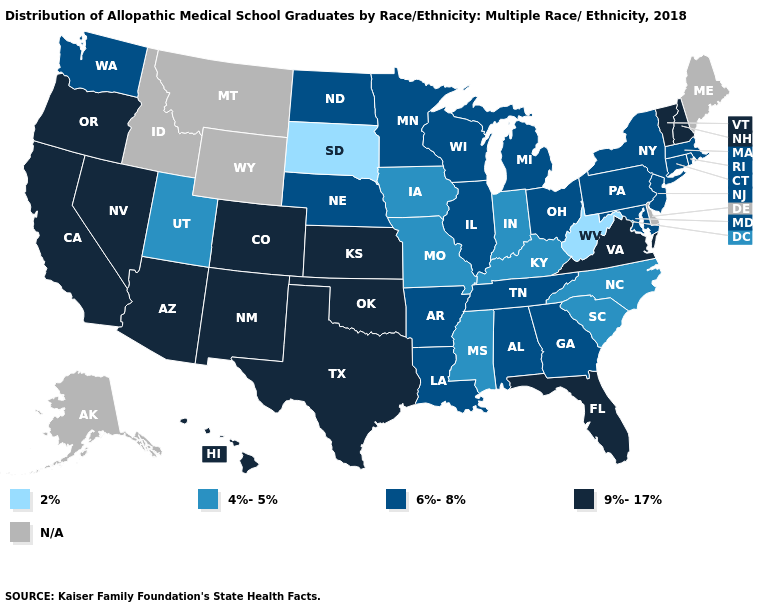Name the states that have a value in the range 2%?
Short answer required. South Dakota, West Virginia. What is the value of Nevada?
Keep it brief. 9%-17%. Name the states that have a value in the range 6%-8%?
Keep it brief. Alabama, Arkansas, Connecticut, Georgia, Illinois, Louisiana, Maryland, Massachusetts, Michigan, Minnesota, Nebraska, New Jersey, New York, North Dakota, Ohio, Pennsylvania, Rhode Island, Tennessee, Washington, Wisconsin. What is the highest value in the South ?
Give a very brief answer. 9%-17%. What is the value of Massachusetts?
Answer briefly. 6%-8%. Does Rhode Island have the highest value in the Northeast?
Give a very brief answer. No. Name the states that have a value in the range 2%?
Concise answer only. South Dakota, West Virginia. Does West Virginia have the lowest value in the USA?
Be succinct. Yes. Which states have the lowest value in the MidWest?
Quick response, please. South Dakota. How many symbols are there in the legend?
Answer briefly. 5. What is the lowest value in the USA?
Be succinct. 2%. What is the lowest value in states that border North Dakota?
Write a very short answer. 2%. Name the states that have a value in the range 2%?
Quick response, please. South Dakota, West Virginia. What is the highest value in the USA?
Keep it brief. 9%-17%. Does the map have missing data?
Give a very brief answer. Yes. 